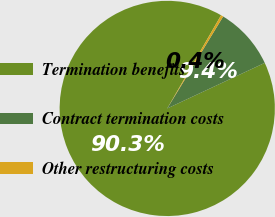Convert chart. <chart><loc_0><loc_0><loc_500><loc_500><pie_chart><fcel>Termination benefits<fcel>Contract termination costs<fcel>Other restructuring costs<nl><fcel>90.29%<fcel>9.35%<fcel>0.36%<nl></chart> 